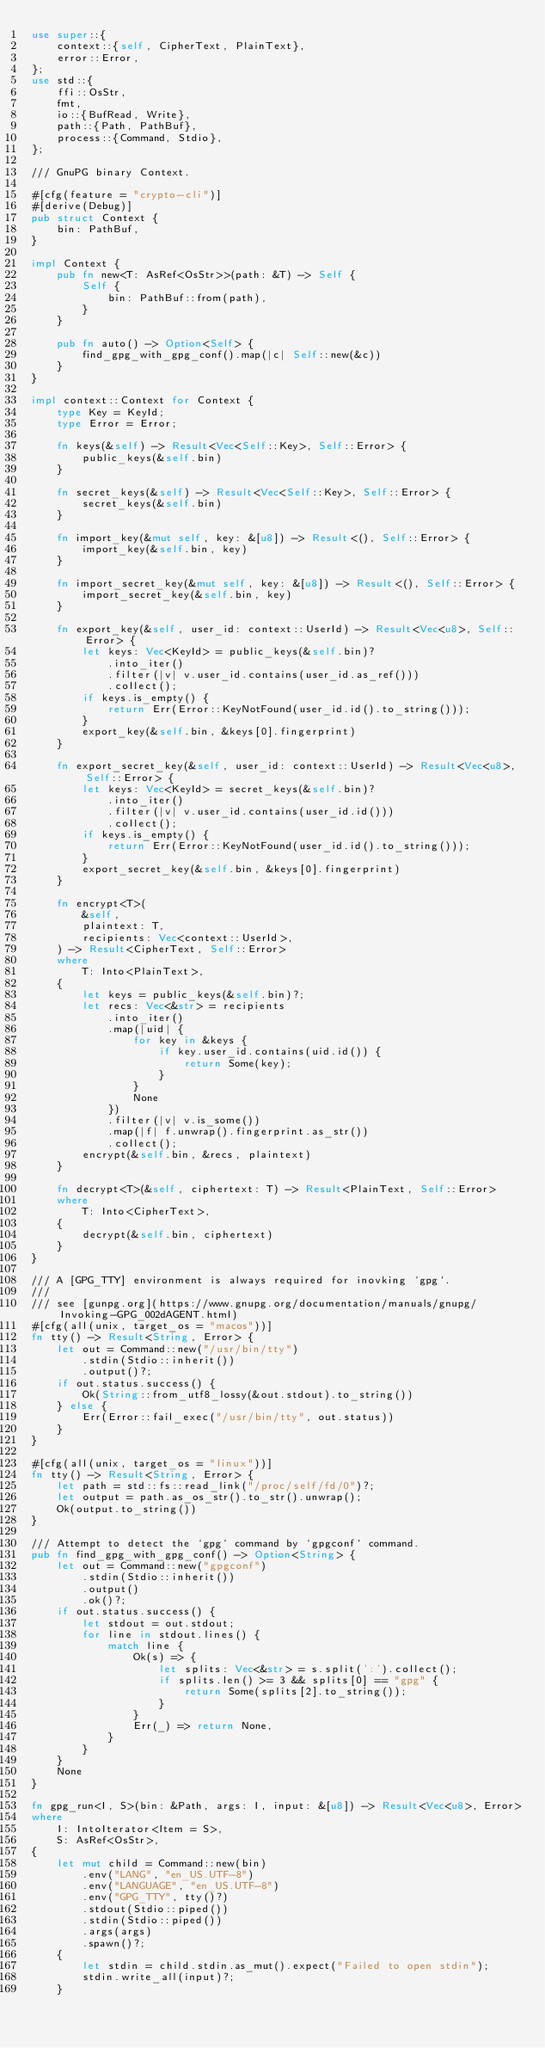Convert code to text. <code><loc_0><loc_0><loc_500><loc_500><_Rust_>use super::{
    context::{self, CipherText, PlainText},
    error::Error,
};
use std::{
    ffi::OsStr,
    fmt,
    io::{BufRead, Write},
    path::{Path, PathBuf},
    process::{Command, Stdio},
};

/// GnuPG binary Context.

#[cfg(feature = "crypto-cli")]
#[derive(Debug)]
pub struct Context {
    bin: PathBuf,
}

impl Context {
    pub fn new<T: AsRef<OsStr>>(path: &T) -> Self {
        Self {
            bin: PathBuf::from(path),
        }
    }

    pub fn auto() -> Option<Self> {
        find_gpg_with_gpg_conf().map(|c| Self::new(&c))
    }
}

impl context::Context for Context {
    type Key = KeyId;
    type Error = Error;

    fn keys(&self) -> Result<Vec<Self::Key>, Self::Error> {
        public_keys(&self.bin)
    }

    fn secret_keys(&self) -> Result<Vec<Self::Key>, Self::Error> {
        secret_keys(&self.bin)
    }

    fn import_key(&mut self, key: &[u8]) -> Result<(), Self::Error> {
        import_key(&self.bin, key)
    }

    fn import_secret_key(&mut self, key: &[u8]) -> Result<(), Self::Error> {
        import_secret_key(&self.bin, key)
    }

    fn export_key(&self, user_id: context::UserId) -> Result<Vec<u8>, Self::Error> {
        let keys: Vec<KeyId> = public_keys(&self.bin)?
            .into_iter()
            .filter(|v| v.user_id.contains(user_id.as_ref()))
            .collect();
        if keys.is_empty() {
            return Err(Error::KeyNotFound(user_id.id().to_string()));
        }
        export_key(&self.bin, &keys[0].fingerprint)
    }

    fn export_secret_key(&self, user_id: context::UserId) -> Result<Vec<u8>, Self::Error> {
        let keys: Vec<KeyId> = secret_keys(&self.bin)?
            .into_iter()
            .filter(|v| v.user_id.contains(user_id.id()))
            .collect();
        if keys.is_empty() {
            return Err(Error::KeyNotFound(user_id.id().to_string()));
        }
        export_secret_key(&self.bin, &keys[0].fingerprint)
    }

    fn encrypt<T>(
        &self,
        plaintext: T,
        recipients: Vec<context::UserId>,
    ) -> Result<CipherText, Self::Error>
    where
        T: Into<PlainText>,
    {
        let keys = public_keys(&self.bin)?;
        let recs: Vec<&str> = recipients
            .into_iter()
            .map(|uid| {
                for key in &keys {
                    if key.user_id.contains(uid.id()) {
                        return Some(key);
                    }
                }
                None
            })
            .filter(|v| v.is_some())
            .map(|f| f.unwrap().fingerprint.as_str())
            .collect();
        encrypt(&self.bin, &recs, plaintext)
    }

    fn decrypt<T>(&self, ciphertext: T) -> Result<PlainText, Self::Error>
    where
        T: Into<CipherText>,
    {
        decrypt(&self.bin, ciphertext)
    }
}

/// A [GPG_TTY] environment is always required for inovking `gpg`.
///
/// see [gunpg.org](https://www.gnupg.org/documentation/manuals/gnupg/Invoking-GPG_002dAGENT.html)
#[cfg(all(unix, target_os = "macos"))]
fn tty() -> Result<String, Error> {
    let out = Command::new("/usr/bin/tty")
        .stdin(Stdio::inherit())
        .output()?;
    if out.status.success() {
        Ok(String::from_utf8_lossy(&out.stdout).to_string())
    } else {
        Err(Error::fail_exec("/usr/bin/tty", out.status))
    }
}

#[cfg(all(unix, target_os = "linux"))]
fn tty() -> Result<String, Error> {
    let path = std::fs::read_link("/proc/self/fd/0")?;
    let output = path.as_os_str().to_str().unwrap();
    Ok(output.to_string())
}

/// Attempt to detect the `gpg` command by `gpgconf` command.
pub fn find_gpg_with_gpg_conf() -> Option<String> {
    let out = Command::new("gpgconf")
        .stdin(Stdio::inherit())
        .output()
        .ok()?;
    if out.status.success() {
        let stdout = out.stdout;
        for line in stdout.lines() {
            match line {
                Ok(s) => {
                    let splits: Vec<&str> = s.split(':').collect();
                    if splits.len() >= 3 && splits[0] == "gpg" {
                        return Some(splits[2].to_string());
                    }
                }
                Err(_) => return None,
            }
        }
    }
    None
}

fn gpg_run<I, S>(bin: &Path, args: I, input: &[u8]) -> Result<Vec<u8>, Error>
where
    I: IntoIterator<Item = S>,
    S: AsRef<OsStr>,
{
    let mut child = Command::new(bin)
        .env("LANG", "en_US.UTF-8")
        .env("LANGUAGE", "en_US.UTF-8")
        .env("GPG_TTY", tty()?)
        .stdout(Stdio::piped())
        .stdin(Stdio::piped())
        .args(args)
        .spawn()?;
    {
        let stdin = child.stdin.as_mut().expect("Failed to open stdin");
        stdin.write_all(input)?;
    }
</code> 